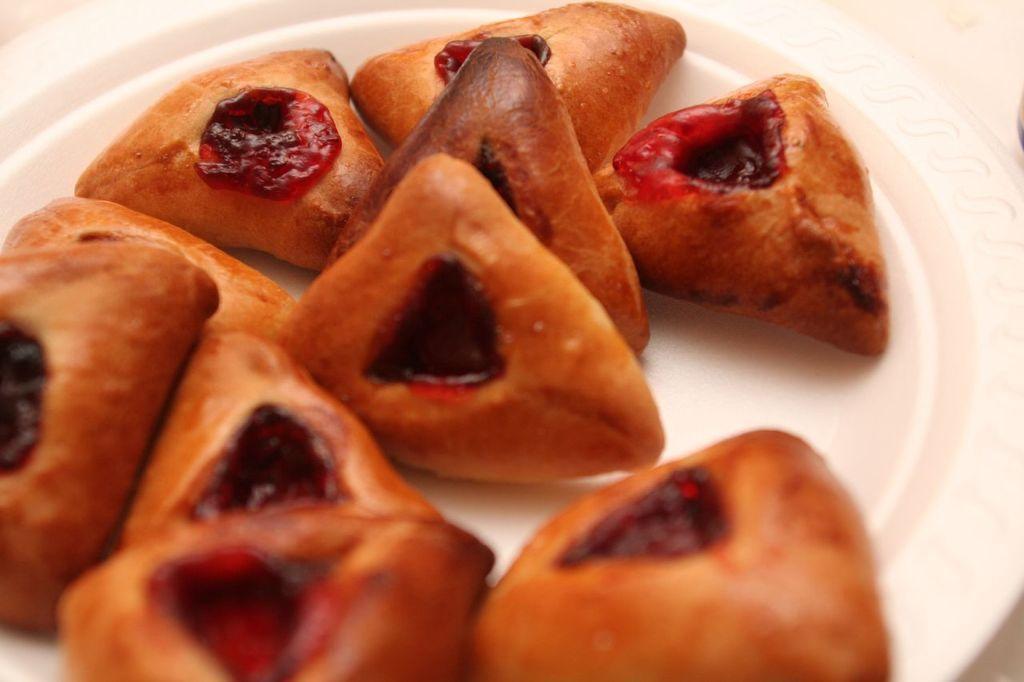In one or two sentences, can you explain what this image depicts? In this picture we can see some food items are placed on the plate. 